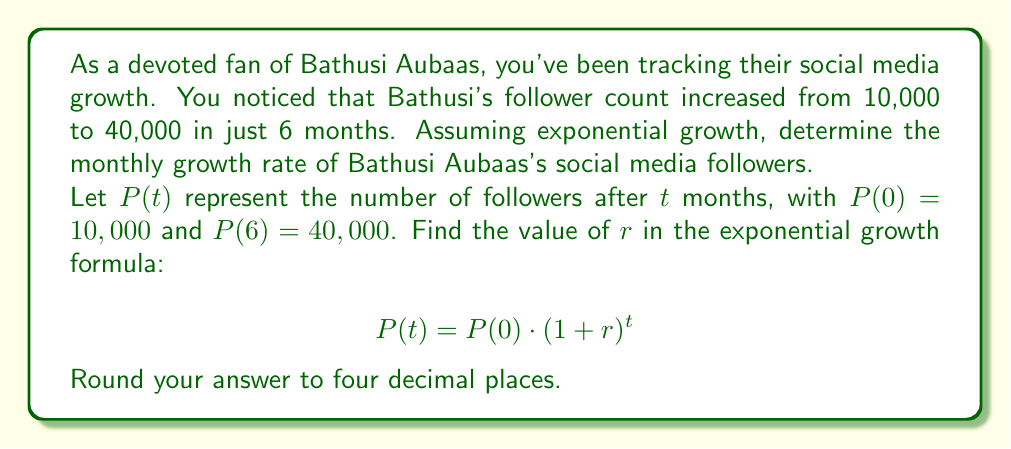Provide a solution to this math problem. To solve this problem, we'll use the exponential growth formula:

$$P(t) = P(0) \cdot (1 + r)^t$$

Where:
$P(t)$ is the number of followers after $t$ months
$P(0)$ is the initial number of followers
$r$ is the monthly growth rate
$t$ is the number of months

We know:
$P(0) = 10,000$
$P(6) = 40,000$
$t = 6$

Let's substitute these values into the formula:

$$40,000 = 10,000 \cdot (1 + r)^6$$

Now, let's solve for $r$:

1) Divide both sides by 10,000:
   $4 = (1 + r)^6$

2) Take the 6th root of both sides:
   $\sqrt[6]{4} = 1 + r$

3) Subtract 1 from both sides:
   $\sqrt[6]{4} - 1 = r$

4) Calculate the value:
   $r = \sqrt[6]{4} - 1 \approx 1.2599 - 1 = 0.2599$

5) Round to four decimal places:
   $r \approx 0.2599$

Therefore, the monthly growth rate is approximately 0.2599 or 25.99%.
Answer: $r \approx 0.2599$ or 25.99% 